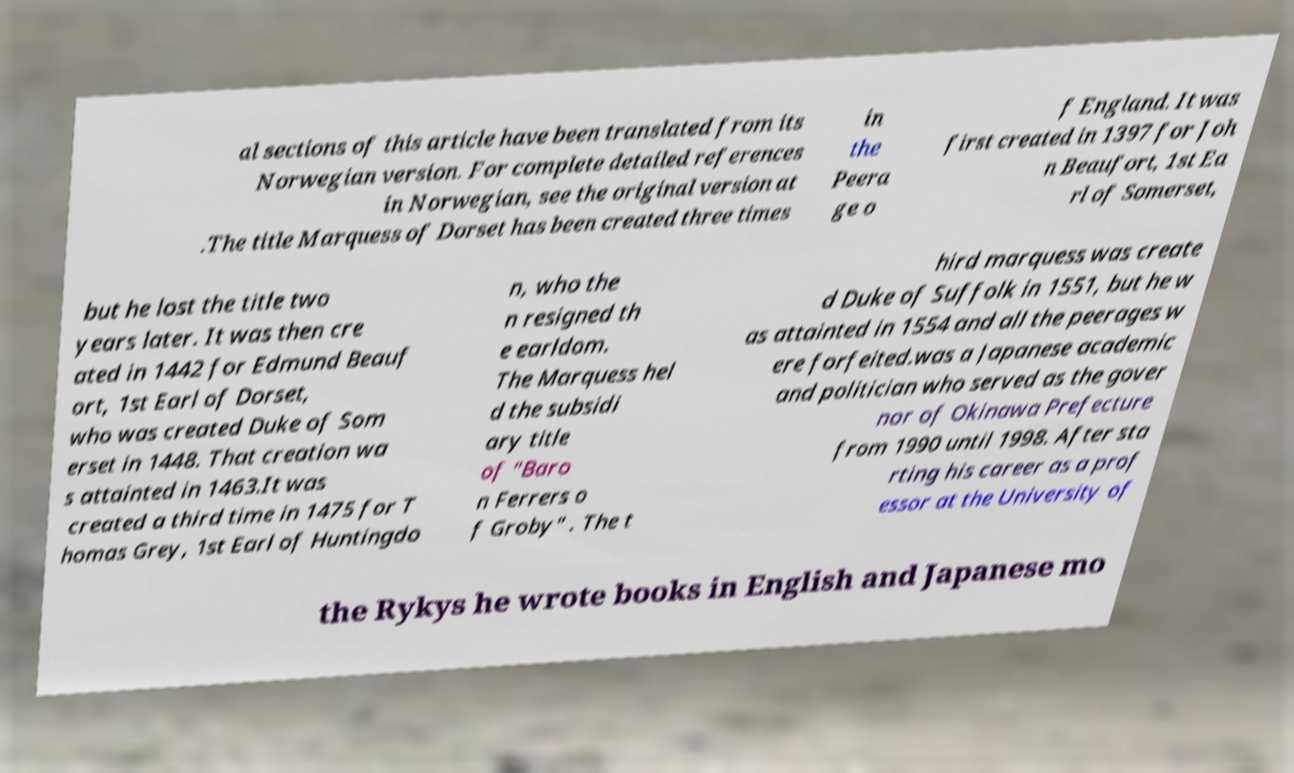For documentation purposes, I need the text within this image transcribed. Could you provide that? al sections of this article have been translated from its Norwegian version. For complete detailed references in Norwegian, see the original version at .The title Marquess of Dorset has been created three times in the Peera ge o f England. It was first created in 1397 for Joh n Beaufort, 1st Ea rl of Somerset, but he lost the title two years later. It was then cre ated in 1442 for Edmund Beauf ort, 1st Earl of Dorset, who was created Duke of Som erset in 1448. That creation wa s attainted in 1463.It was created a third time in 1475 for T homas Grey, 1st Earl of Huntingdo n, who the n resigned th e earldom. The Marquess hel d the subsidi ary title of "Baro n Ferrers o f Groby" . The t hird marquess was create d Duke of Suffolk in 1551, but he w as attainted in 1554 and all the peerages w ere forfeited.was a Japanese academic and politician who served as the gover nor of Okinawa Prefecture from 1990 until 1998. After sta rting his career as a prof essor at the University of the Rykys he wrote books in English and Japanese mo 